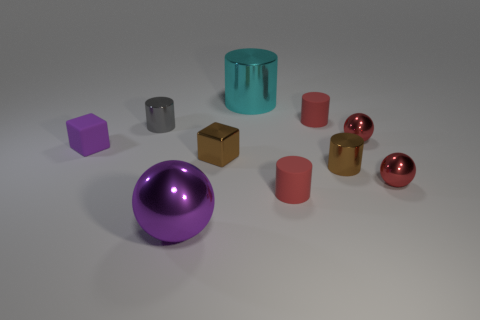Are there more rubber cubes than metallic things?
Provide a succinct answer. No. There is a tiny metallic object that is left of the big purple shiny ball; does it have the same shape as the tiny purple matte object?
Ensure brevity in your answer.  No. What number of large things are in front of the small brown metal cylinder and on the right side of the big purple object?
Provide a short and direct response. 0. How many tiny matte things have the same shape as the large cyan thing?
Offer a very short reply. 2. There is a small metallic object on the left side of the cube on the right side of the purple shiny ball; what is its color?
Make the answer very short. Gray. There is a tiny gray object; does it have the same shape as the purple object behind the brown metallic block?
Your answer should be compact. No. What is the material of the red object that is behind the metallic ball behind the block left of the tiny brown cube?
Give a very brief answer. Rubber. Are there any red spheres of the same size as the purple rubber object?
Give a very brief answer. Yes. There is a gray cylinder that is the same material as the big purple object; what is its size?
Your answer should be very brief. Small. The purple matte thing has what shape?
Ensure brevity in your answer.  Cube. 